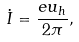<formula> <loc_0><loc_0><loc_500><loc_500>\dot { I } = \frac { e u _ { h } } { 2 \pi } ,</formula> 